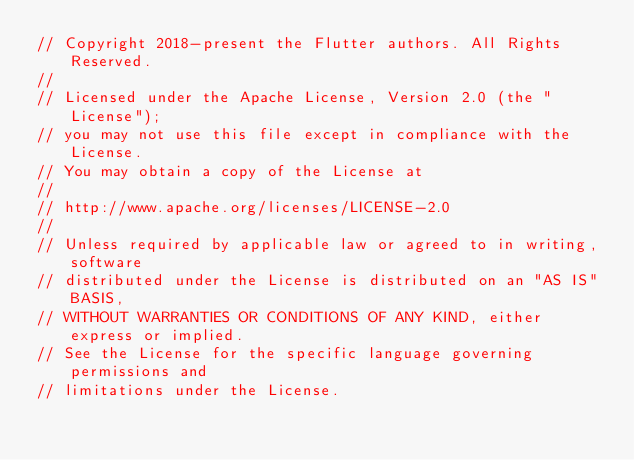Convert code to text. <code><loc_0><loc_0><loc_500><loc_500><_Dart_>// Copyright 2018-present the Flutter authors. All Rights Reserved.
//
// Licensed under the Apache License, Version 2.0 (the "License");
// you may not use this file except in compliance with the License.
// You may obtain a copy of the License at
//
// http://www.apache.org/licenses/LICENSE-2.0
//
// Unless required by applicable law or agreed to in writing, software
// distributed under the License is distributed on an "AS IS" BASIS,
// WITHOUT WARRANTIES OR CONDITIONS OF ANY KIND, either express or implied.
// See the License for the specific language governing permissions and
// limitations under the License.
</code> 